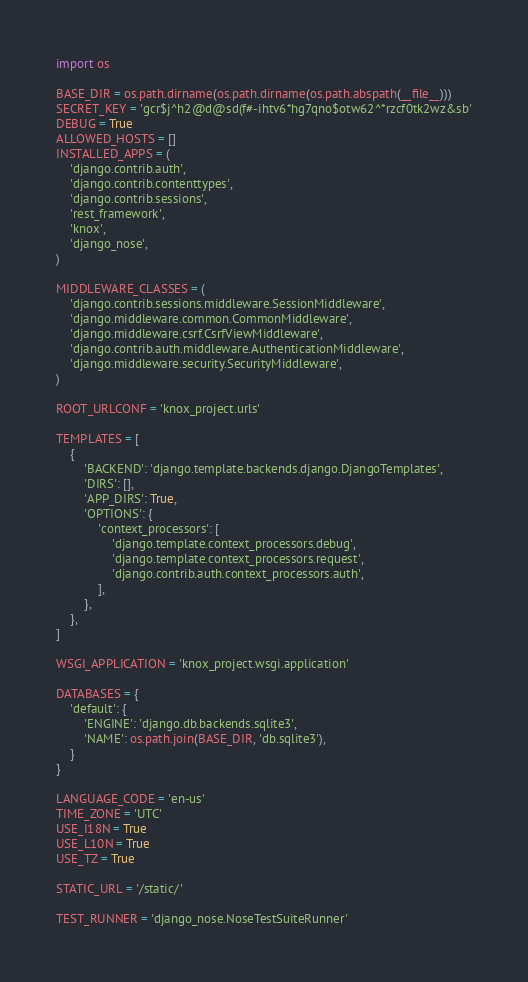<code> <loc_0><loc_0><loc_500><loc_500><_Python_>import os

BASE_DIR = os.path.dirname(os.path.dirname(os.path.abspath(__file__)))
SECRET_KEY = 'gcr$j^h2@d@sd(f#-ihtv6*hg7qno$otw62^*rzcf0tk2wz&sb'
DEBUG = True
ALLOWED_HOSTS = []
INSTALLED_APPS = (
    'django.contrib.auth',
    'django.contrib.contenttypes',
    'django.contrib.sessions',
    'rest_framework',
    'knox',
    'django_nose',
)

MIDDLEWARE_CLASSES = (
    'django.contrib.sessions.middleware.SessionMiddleware',
    'django.middleware.common.CommonMiddleware',
    'django.middleware.csrf.CsrfViewMiddleware',
    'django.contrib.auth.middleware.AuthenticationMiddleware',
    'django.middleware.security.SecurityMiddleware',
)

ROOT_URLCONF = 'knox_project.urls'

TEMPLATES = [
    {
        'BACKEND': 'django.template.backends.django.DjangoTemplates',
        'DIRS': [],
        'APP_DIRS': True,
        'OPTIONS': {
            'context_processors': [
                'django.template.context_processors.debug',
                'django.template.context_processors.request',
                'django.contrib.auth.context_processors.auth',
            ],
        },
    },
]

WSGI_APPLICATION = 'knox_project.wsgi.application'

DATABASES = {
    'default': {
        'ENGINE': 'django.db.backends.sqlite3',
        'NAME': os.path.join(BASE_DIR, 'db.sqlite3'),
    }
}

LANGUAGE_CODE = 'en-us'
TIME_ZONE = 'UTC'
USE_I18N = True
USE_L10N = True
USE_TZ = True

STATIC_URL = '/static/'

TEST_RUNNER = 'django_nose.NoseTestSuiteRunner'
</code> 